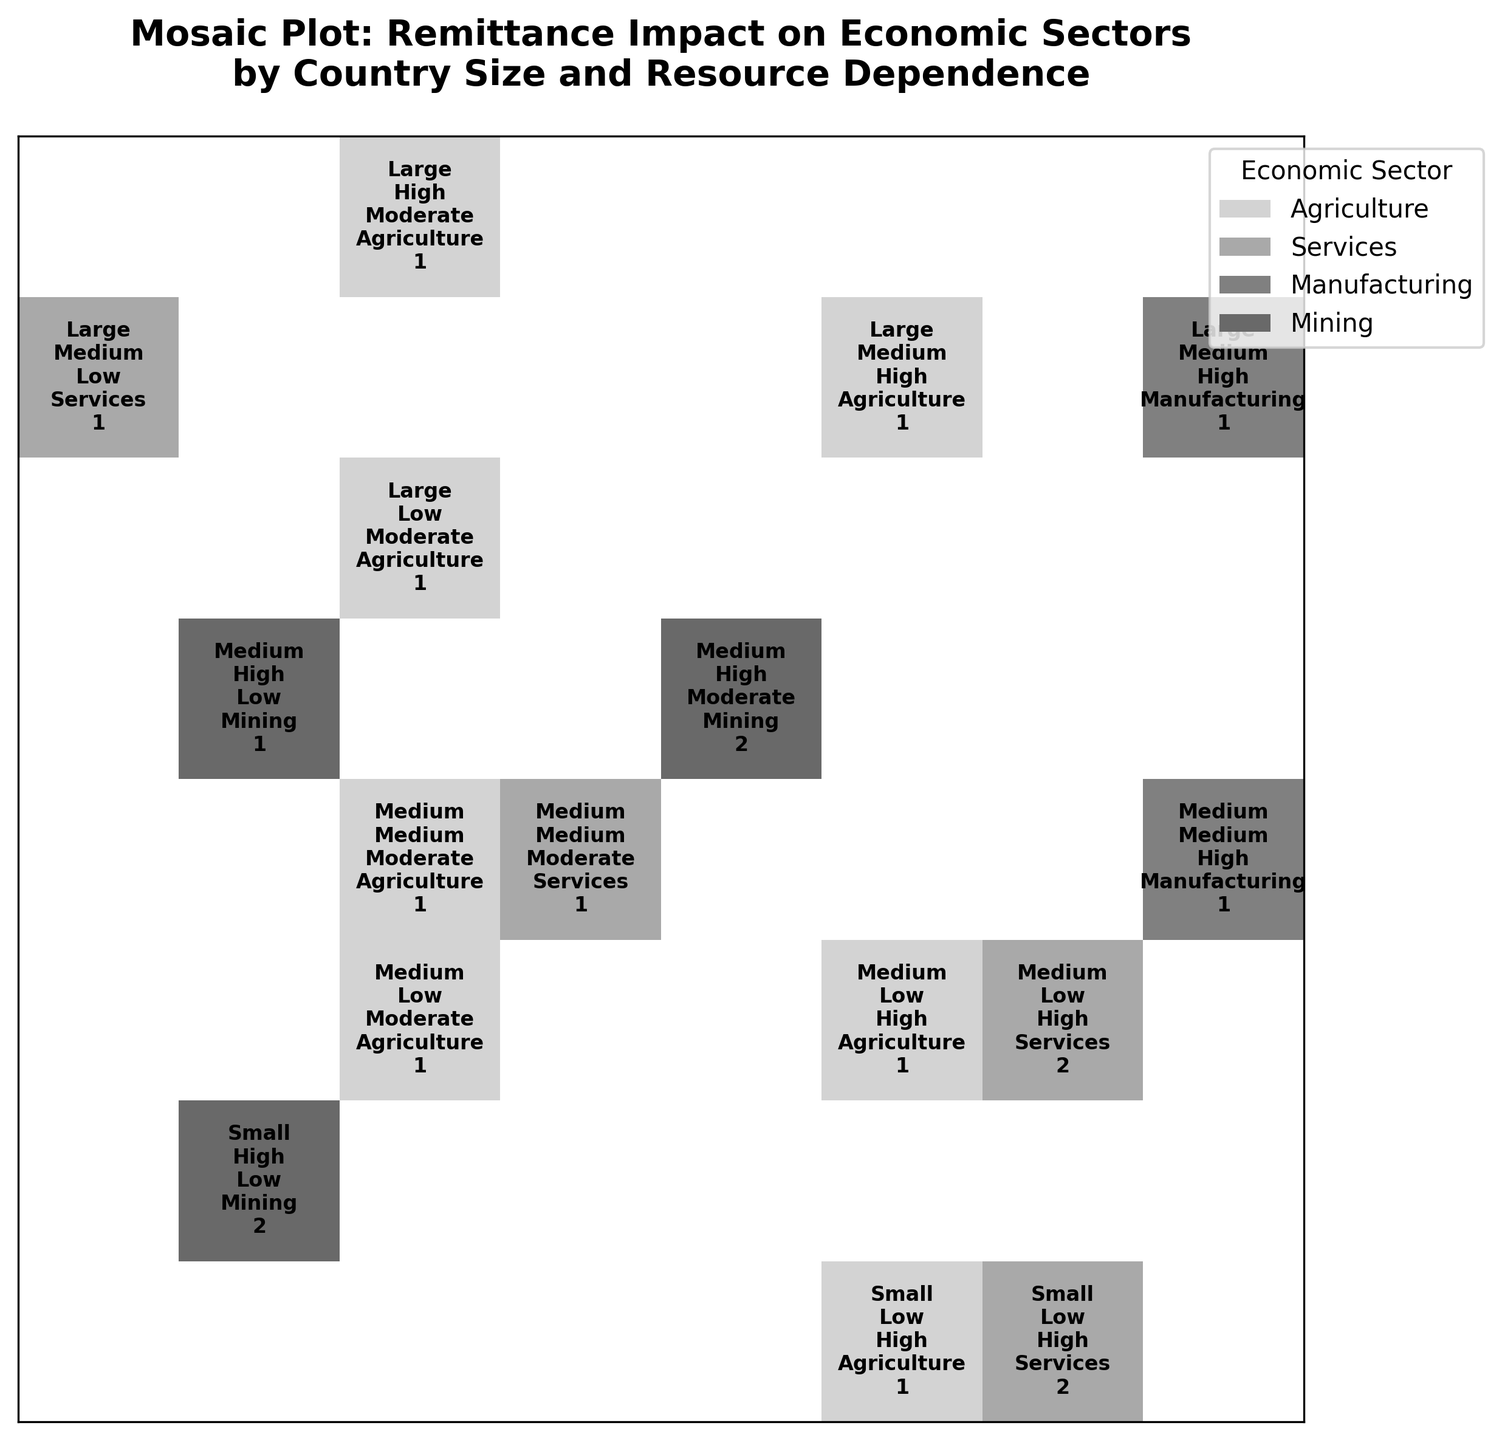Which country size appears most frequently in the economic sectors across the plot? Large countries appear in five instances across various sectors, while Medium and Small countries appear in many instances but fewer than Large.
Answer: Large Which economic sector is most frequently impacted by high remittances? Services have the most high remittance impacts, as seen in Kenya, Senegal, Morocco, and Rwanda.
Answer: Services How many Medium-sized countries primarily rely on mining and receive low remittance impacts? Both Angola and Zimbabwe fit this description (Medium size, mining, low remittance impact), totaling two countries.
Answer: 2 Is there any Small-sized country with high resource dependence and low remittance impact? Yes, there are two small-sized countries with high resource dependence and low remittance impact: Zimbabwe and Namibia.
Answer: Yes Which country size has the highest variety of economic sectors shown in the plot? Medium-sized countries show the highest variety with representation in Agriculture, Services, Manufacturing, and Mining.
Answer: Medium For Large-sized countries with moderate or high remittance impacts, which economic sectors are represented? Agriculture, Services, and Manufacturing are represented by large countries with moderate or high remittance impacts.
Answer: Agriculture, Services, Manufacturing Which economic sector is associated with the highest remittance impact in both Large and Medium-sized countries? Manufacturing appears in both Large (Egypt) and Medium (Ghana) countries with a high remittance impact.
Answer: Manufacturing Are there any economic sectors exclusively linked to a particular country size? No sector appears exclusively in one country size; each sector is mixed across various country sizes.
Answer: No In countries with medium resource dependence, what is the most common remittance impact level across all economic sectors? Moderate remittance impact appears most frequently in countries with medium resource dependence.
Answer: Moderate 